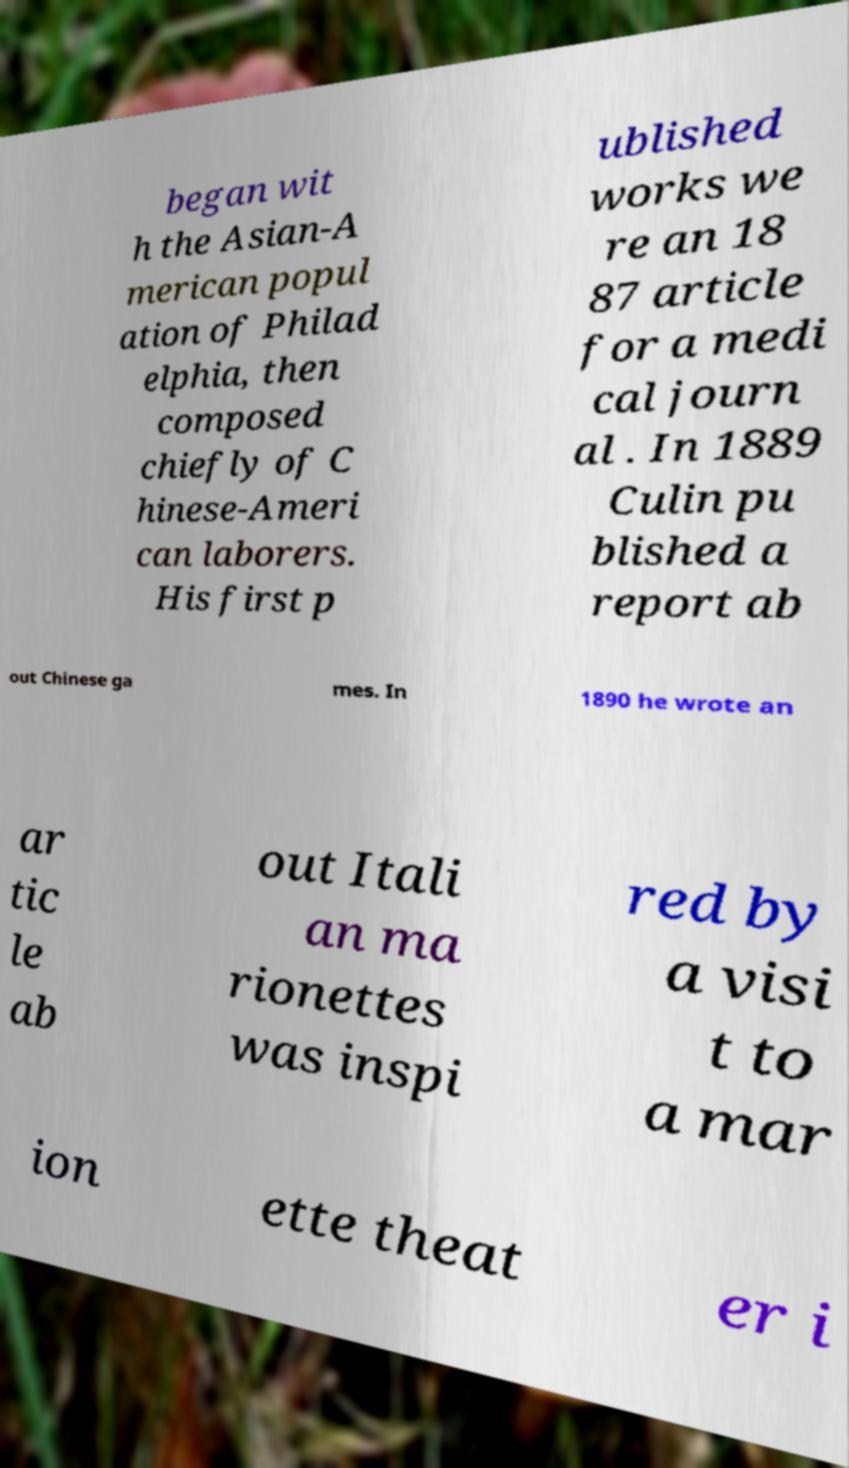Can you accurately transcribe the text from the provided image for me? began wit h the Asian-A merican popul ation of Philad elphia, then composed chiefly of C hinese-Ameri can laborers. His first p ublished works we re an 18 87 article for a medi cal journ al . In 1889 Culin pu blished a report ab out Chinese ga mes. In 1890 he wrote an ar tic le ab out Itali an ma rionettes was inspi red by a visi t to a mar ion ette theat er i 